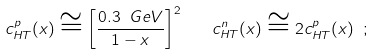<formula> <loc_0><loc_0><loc_500><loc_500>c _ { H T } ^ { p } ( x ) \cong \left [ \frac { 0 . 3 \ G e V } { 1 - x } \right ] ^ { 2 } \quad c _ { H T } ^ { n } ( x ) \cong 2 c _ { H T } ^ { p } ( x ) \ ;</formula> 